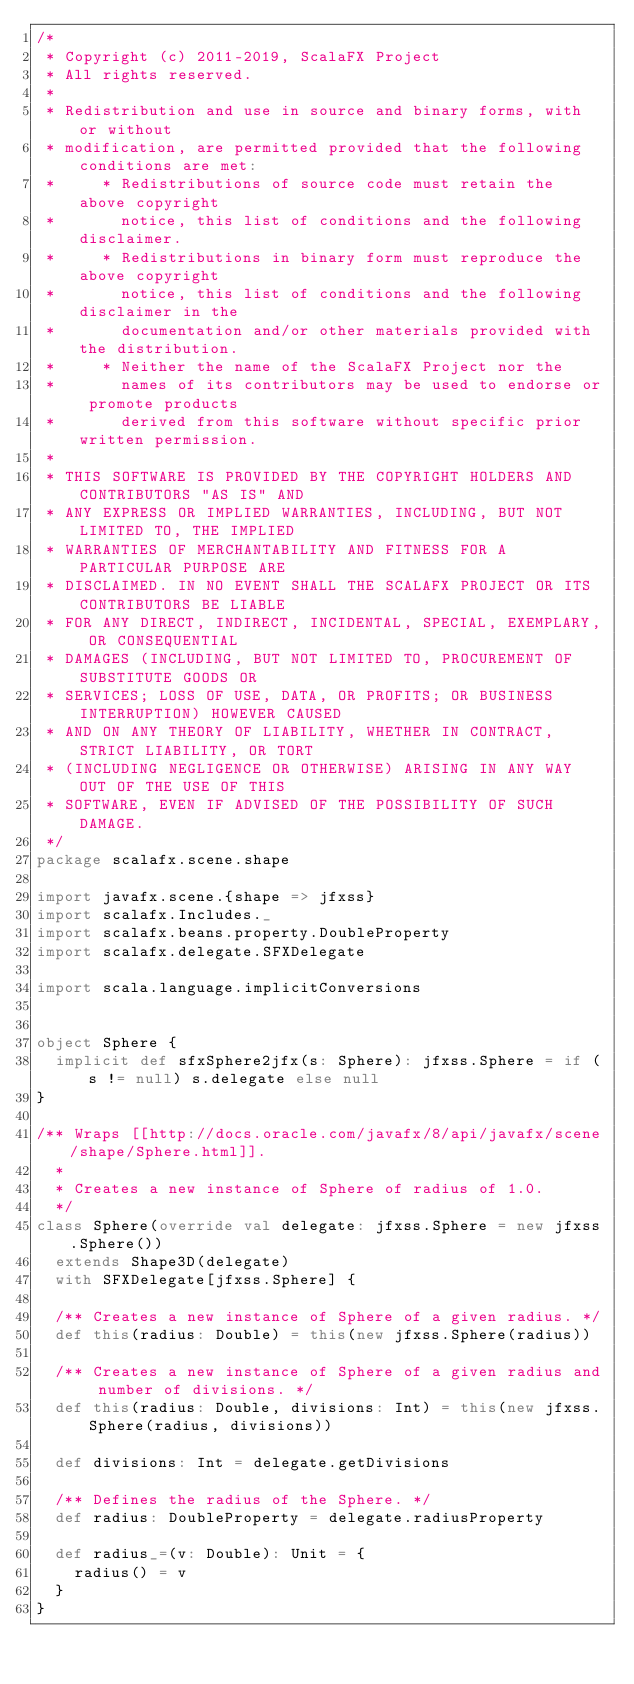<code> <loc_0><loc_0><loc_500><loc_500><_Scala_>/*
 * Copyright (c) 2011-2019, ScalaFX Project
 * All rights reserved.
 *
 * Redistribution and use in source and binary forms, with or without
 * modification, are permitted provided that the following conditions are met:
 *     * Redistributions of source code must retain the above copyright
 *       notice, this list of conditions and the following disclaimer.
 *     * Redistributions in binary form must reproduce the above copyright
 *       notice, this list of conditions and the following disclaimer in the
 *       documentation and/or other materials provided with the distribution.
 *     * Neither the name of the ScalaFX Project nor the
 *       names of its contributors may be used to endorse or promote products
 *       derived from this software without specific prior written permission.
 *
 * THIS SOFTWARE IS PROVIDED BY THE COPYRIGHT HOLDERS AND CONTRIBUTORS "AS IS" AND
 * ANY EXPRESS OR IMPLIED WARRANTIES, INCLUDING, BUT NOT LIMITED TO, THE IMPLIED
 * WARRANTIES OF MERCHANTABILITY AND FITNESS FOR A PARTICULAR PURPOSE ARE
 * DISCLAIMED. IN NO EVENT SHALL THE SCALAFX PROJECT OR ITS CONTRIBUTORS BE LIABLE
 * FOR ANY DIRECT, INDIRECT, INCIDENTAL, SPECIAL, EXEMPLARY, OR CONSEQUENTIAL
 * DAMAGES (INCLUDING, BUT NOT LIMITED TO, PROCUREMENT OF SUBSTITUTE GOODS OR
 * SERVICES; LOSS OF USE, DATA, OR PROFITS; OR BUSINESS INTERRUPTION) HOWEVER CAUSED
 * AND ON ANY THEORY OF LIABILITY, WHETHER IN CONTRACT, STRICT LIABILITY, OR TORT
 * (INCLUDING NEGLIGENCE OR OTHERWISE) ARISING IN ANY WAY OUT OF THE USE OF THIS
 * SOFTWARE, EVEN IF ADVISED OF THE POSSIBILITY OF SUCH DAMAGE.
 */
package scalafx.scene.shape

import javafx.scene.{shape => jfxss}
import scalafx.Includes._
import scalafx.beans.property.DoubleProperty
import scalafx.delegate.SFXDelegate

import scala.language.implicitConversions


object Sphere {
  implicit def sfxSphere2jfx(s: Sphere): jfxss.Sphere = if (s != null) s.delegate else null
}

/** Wraps [[http://docs.oracle.com/javafx/8/api/javafx/scene/shape/Sphere.html]].
  *
  * Creates a new instance of Sphere of radius of 1.0.
  */
class Sphere(override val delegate: jfxss.Sphere = new jfxss.Sphere())
  extends Shape3D(delegate)
  with SFXDelegate[jfxss.Sphere] {

  /** Creates a new instance of Sphere of a given radius. */
  def this(radius: Double) = this(new jfxss.Sphere(radius))

  /** Creates a new instance of Sphere of a given radius and number of divisions. */
  def this(radius: Double, divisions: Int) = this(new jfxss.Sphere(radius, divisions))

  def divisions: Int = delegate.getDivisions

  /** Defines the radius of the Sphere. */
  def radius: DoubleProperty = delegate.radiusProperty

  def radius_=(v: Double): Unit = {
    radius() = v
  }
}
</code> 